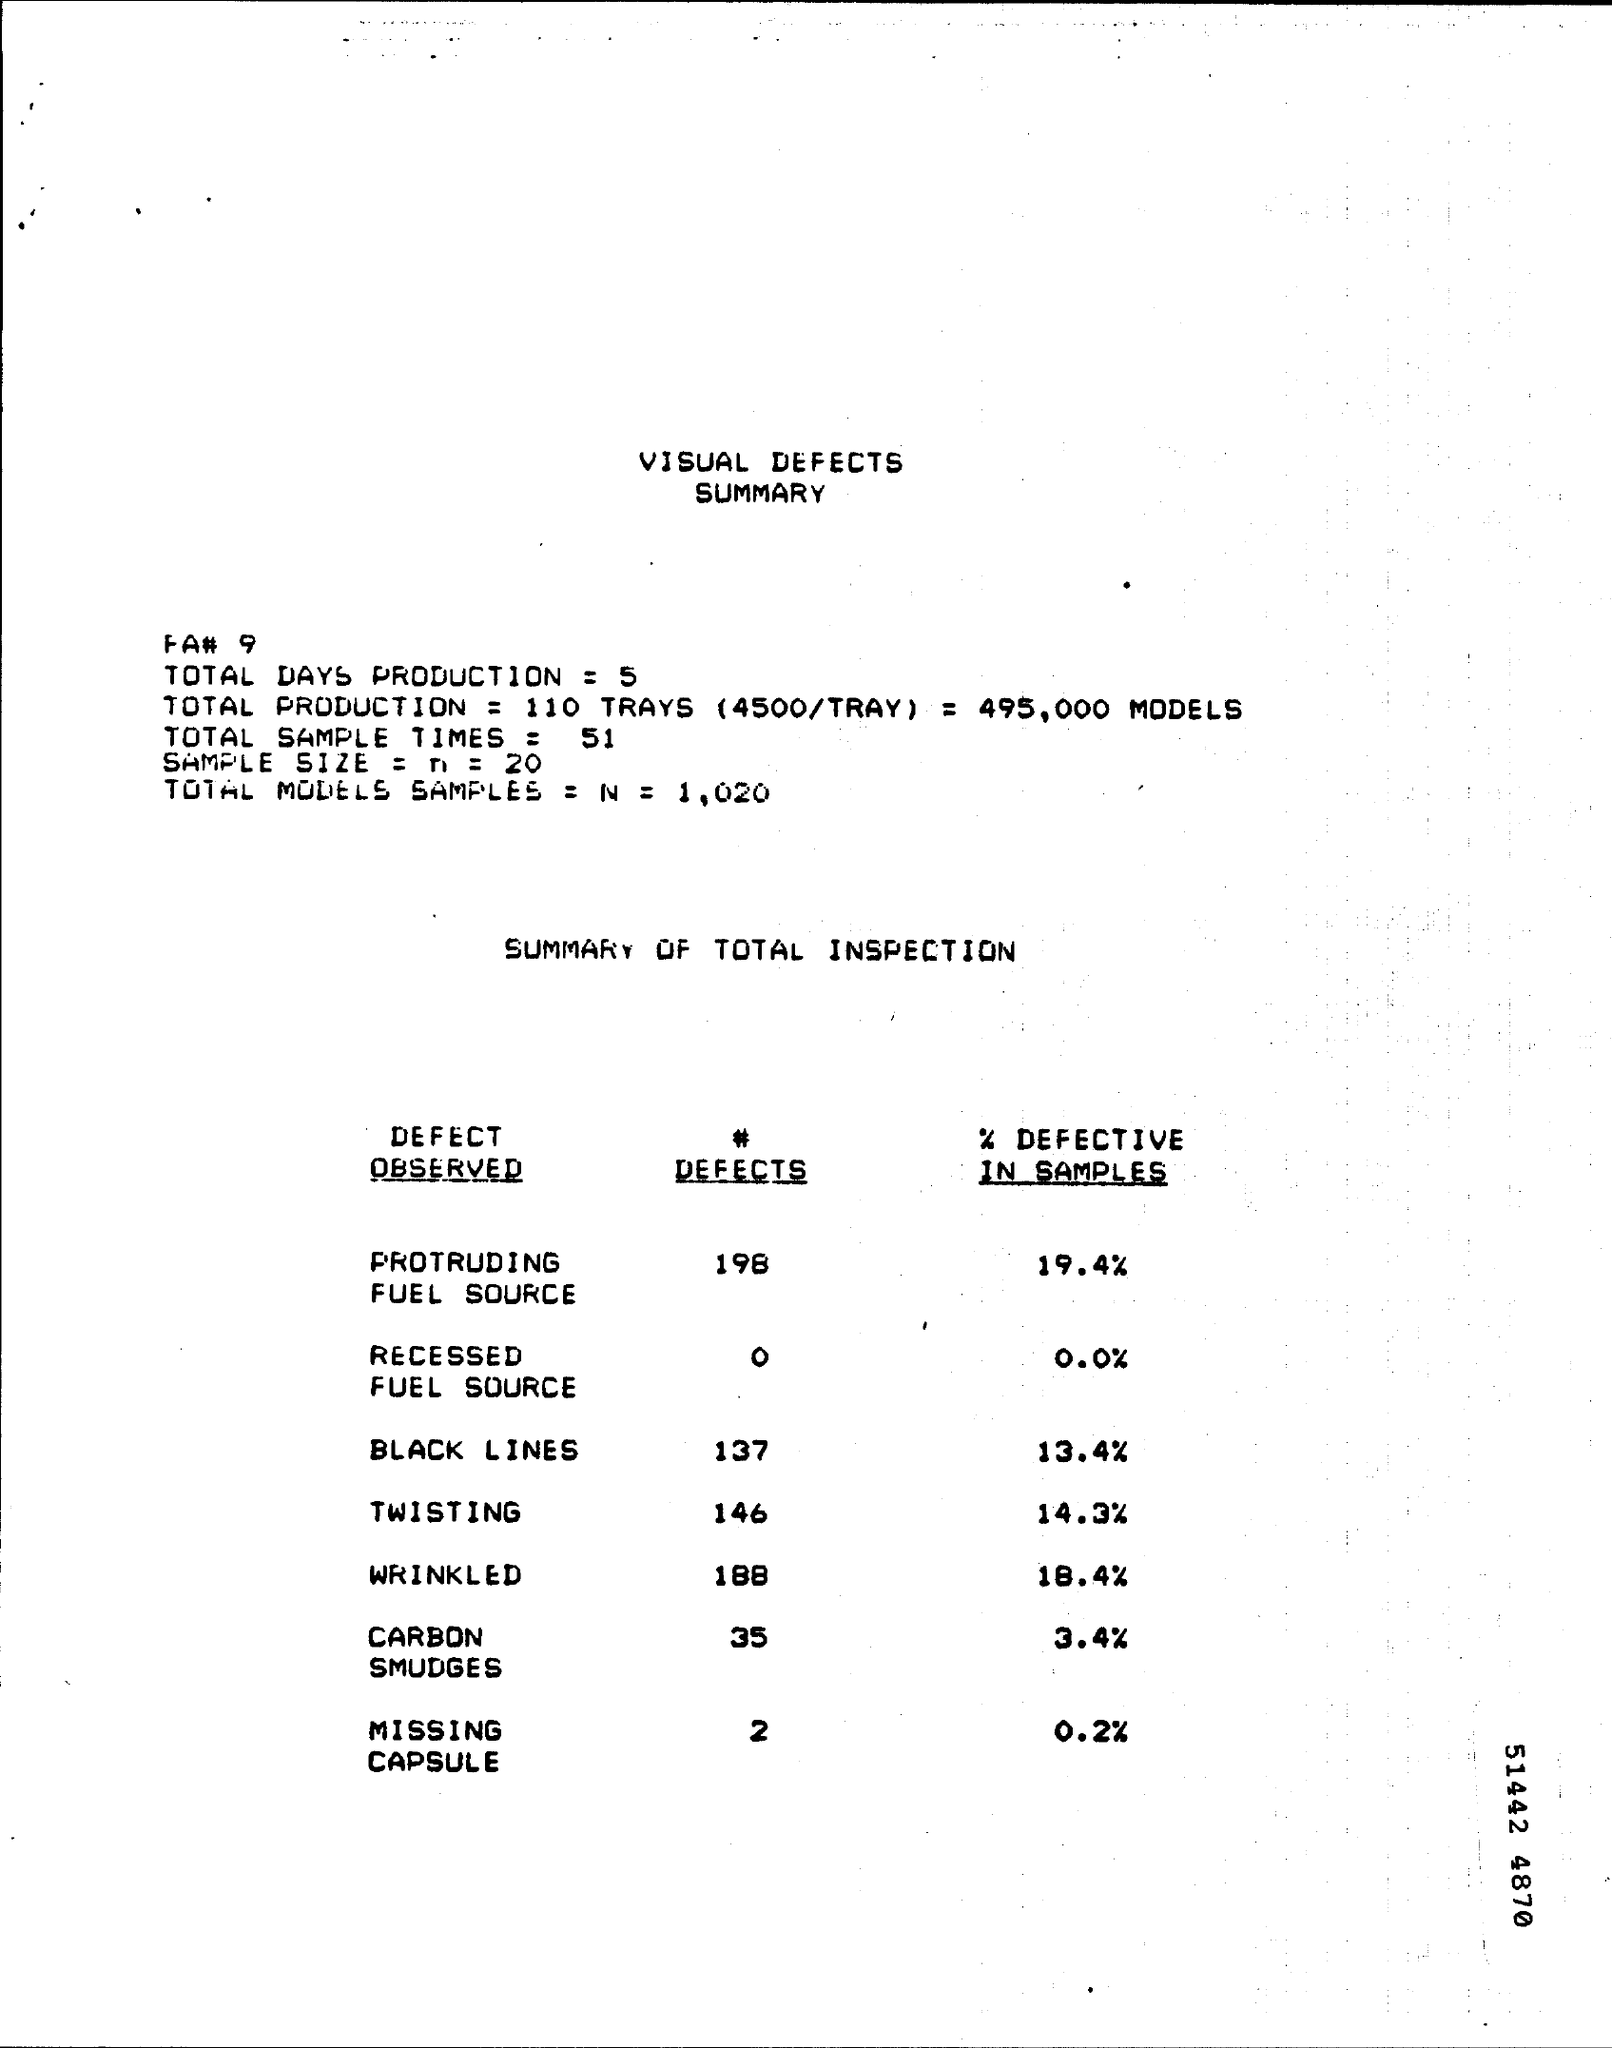Give some essential details in this illustration. There are 2 defects of missing capsules. The text "How many # Defects of Twisting? 146.." is a tweet that contains a question and a number. The question is asking how many defects of twisting there are, and the number provided is 146. There are 35 defects related to carbon smudges. There were 188 defects related to wrinkling. The total sample times are 51... 